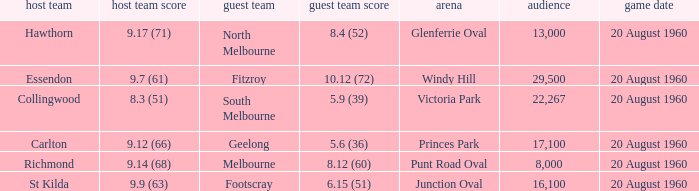What is the attendance figure of the game when fitzroy is the opposing team? 1.0. 